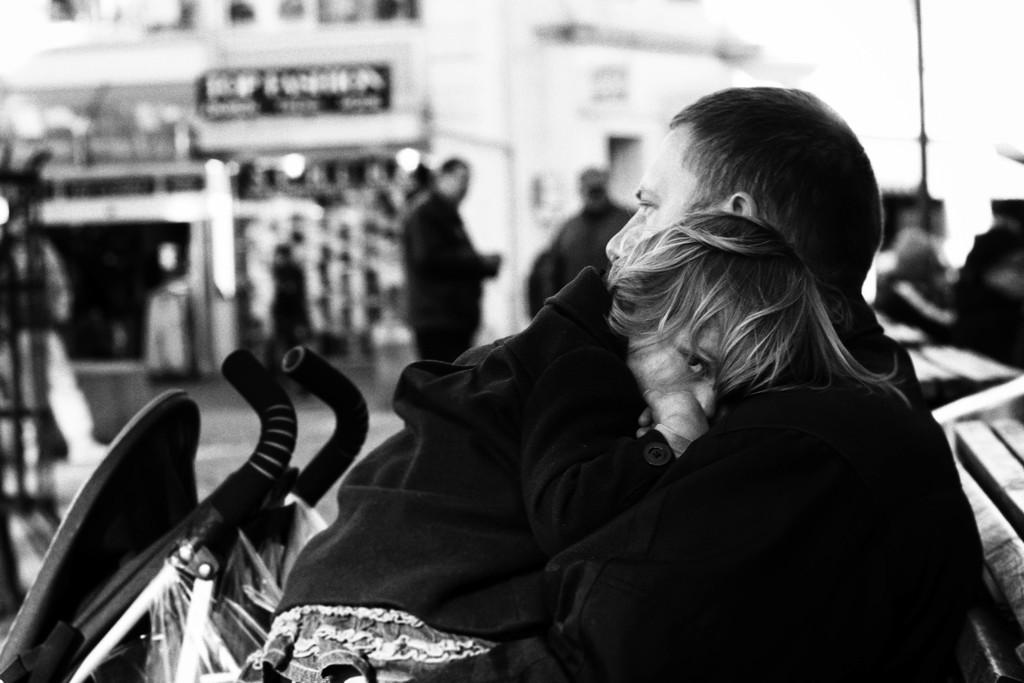Who or what is present in the image? There are people in the image. What color scheme is used in the image? The image is black and white in color. What type of vegetable is being used as a prop in the image? There is no vegetable present in the image. Is there any wax visible in the image? There is no wax visible in the image. 